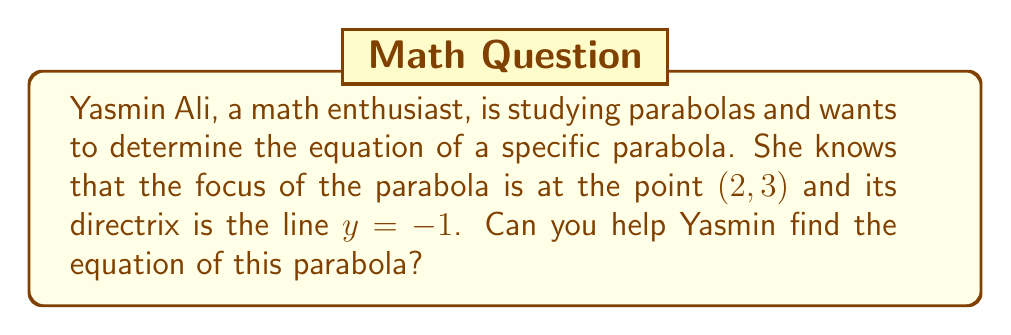Help me with this question. To find the equation of a parabola given its focus and directrix, we can follow these steps:

1) The general equation of a parabola with a vertical axis of symmetry is:
   $$(x-h)^2 = 4p(y-k)$$
   where (h,k) is the vertex and p is the distance from the vertex to the focus.

2) The focus is given as (2, 3), so we know that h = 2.

3) The directrix is y = -1. The distance from the focus to the directrix is:
   $$3 - (-1) = 4$$

4) The vertex is halfway between the focus and the directrix. So:
   $$k = \frac{3 + (-1)}{2} = 1$$

5) The distance p from the vertex to the focus is half of the distance from the focus to the directrix:
   $$p = \frac{4}{2} = 2$$

6) Now we can substitute these values into our general equation:
   $$(x-2)^2 = 4(2)(y-1)$$

7) Simplify:
   $$(x-2)^2 = 8(y-1)$$

This is the equation of the parabola in standard form.
Answer: The equation of the parabola is $(x-2)^2 = 8(y-1)$ 